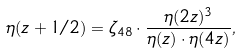<formula> <loc_0><loc_0><loc_500><loc_500>\eta ( z + 1 / 2 ) = \zeta _ { 4 8 } \cdot \frac { \eta ( 2 z ) ^ { 3 } } { \eta ( z ) \cdot \eta ( 4 z ) } ,</formula> 